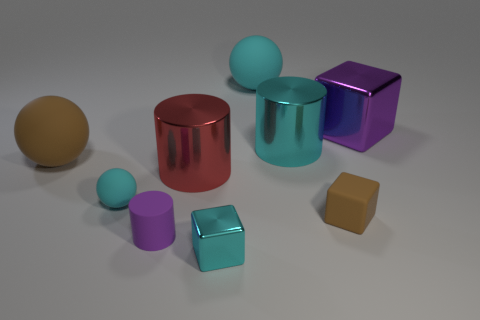What is the color of the small matte ball?
Give a very brief answer. Cyan. Do the big block and the matte cylinder that is in front of the purple block have the same color?
Provide a succinct answer. Yes. Is there a yellow metallic sphere that has the same size as the red cylinder?
Ensure brevity in your answer.  No. What size is the object that is the same color as the tiny rubber cylinder?
Provide a succinct answer. Large. There is a ball that is on the right side of the tiny purple cylinder; what is its material?
Ensure brevity in your answer.  Rubber. Are there an equal number of cyan objects behind the brown block and cyan matte objects that are on the left side of the large cyan matte object?
Provide a short and direct response. No. There is a cyan sphere behind the big cyan metal thing; is it the same size as the cyan rubber sphere in front of the big brown object?
Offer a terse response. No. What number of small cylinders are the same color as the small sphere?
Make the answer very short. 0. There is a thing that is the same color as the rubber cylinder; what is its material?
Offer a very short reply. Metal. Are there more metal cylinders in front of the brown rubber sphere than large blue metal cubes?
Your answer should be very brief. Yes. 